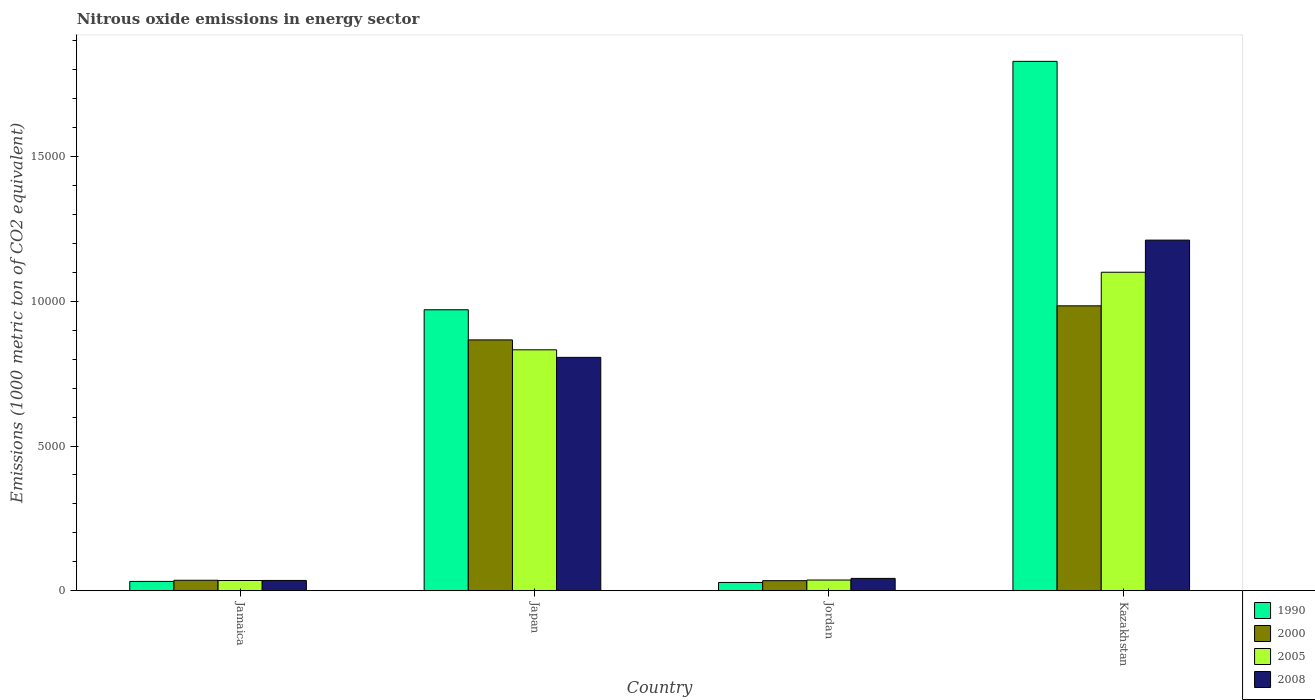How many groups of bars are there?
Offer a terse response. 4. Are the number of bars per tick equal to the number of legend labels?
Offer a very short reply. Yes. Are the number of bars on each tick of the X-axis equal?
Your answer should be compact. Yes. How many bars are there on the 3rd tick from the right?
Your response must be concise. 4. What is the label of the 1st group of bars from the left?
Give a very brief answer. Jamaica. In how many cases, is the number of bars for a given country not equal to the number of legend labels?
Provide a short and direct response. 0. What is the amount of nitrous oxide emitted in 2005 in Japan?
Offer a very short reply. 8324.7. Across all countries, what is the maximum amount of nitrous oxide emitted in 1990?
Give a very brief answer. 1.83e+04. Across all countries, what is the minimum amount of nitrous oxide emitted in 1990?
Make the answer very short. 285.6. In which country was the amount of nitrous oxide emitted in 2005 maximum?
Ensure brevity in your answer.  Kazakhstan. In which country was the amount of nitrous oxide emitted in 2000 minimum?
Ensure brevity in your answer.  Jordan. What is the total amount of nitrous oxide emitted in 2000 in the graph?
Your response must be concise. 1.92e+04. What is the difference between the amount of nitrous oxide emitted in 2008 in Jamaica and that in Jordan?
Your answer should be very brief. -70.9. What is the difference between the amount of nitrous oxide emitted in 1990 in Jamaica and the amount of nitrous oxide emitted in 2008 in Kazakhstan?
Provide a succinct answer. -1.18e+04. What is the average amount of nitrous oxide emitted in 2000 per country?
Your answer should be very brief. 4805.08. What is the difference between the amount of nitrous oxide emitted of/in 2005 and amount of nitrous oxide emitted of/in 2008 in Jamaica?
Your answer should be compact. -1.3. In how many countries, is the amount of nitrous oxide emitted in 1990 greater than 6000 1000 metric ton?
Provide a short and direct response. 2. What is the ratio of the amount of nitrous oxide emitted in 2000 in Jordan to that in Kazakhstan?
Provide a succinct answer. 0.04. Is the difference between the amount of nitrous oxide emitted in 2005 in Japan and Jordan greater than the difference between the amount of nitrous oxide emitted in 2008 in Japan and Jordan?
Your answer should be compact. Yes. What is the difference between the highest and the second highest amount of nitrous oxide emitted in 1990?
Ensure brevity in your answer.  -1.80e+04. What is the difference between the highest and the lowest amount of nitrous oxide emitted in 2005?
Offer a very short reply. 1.07e+04. In how many countries, is the amount of nitrous oxide emitted in 2008 greater than the average amount of nitrous oxide emitted in 2008 taken over all countries?
Your response must be concise. 2. Is it the case that in every country, the sum of the amount of nitrous oxide emitted in 2005 and amount of nitrous oxide emitted in 2000 is greater than the sum of amount of nitrous oxide emitted in 1990 and amount of nitrous oxide emitted in 2008?
Keep it short and to the point. No. How many bars are there?
Offer a very short reply. 16. How many countries are there in the graph?
Offer a very short reply. 4. Are the values on the major ticks of Y-axis written in scientific E-notation?
Offer a terse response. No. Does the graph contain grids?
Offer a terse response. No. Where does the legend appear in the graph?
Give a very brief answer. Bottom right. How are the legend labels stacked?
Give a very brief answer. Vertical. What is the title of the graph?
Offer a terse response. Nitrous oxide emissions in energy sector. What is the label or title of the X-axis?
Keep it short and to the point. Country. What is the label or title of the Y-axis?
Offer a very short reply. Emissions (1000 metric ton of CO2 equivalent). What is the Emissions (1000 metric ton of CO2 equivalent) in 1990 in Jamaica?
Offer a very short reply. 321.7. What is the Emissions (1000 metric ton of CO2 equivalent) of 2000 in Jamaica?
Provide a short and direct response. 361.6. What is the Emissions (1000 metric ton of CO2 equivalent) in 2005 in Jamaica?
Keep it short and to the point. 353.5. What is the Emissions (1000 metric ton of CO2 equivalent) of 2008 in Jamaica?
Offer a very short reply. 354.8. What is the Emissions (1000 metric ton of CO2 equivalent) of 1990 in Japan?
Your answer should be very brief. 9708.8. What is the Emissions (1000 metric ton of CO2 equivalent) in 2000 in Japan?
Ensure brevity in your answer.  8667.2. What is the Emissions (1000 metric ton of CO2 equivalent) of 2005 in Japan?
Offer a very short reply. 8324.7. What is the Emissions (1000 metric ton of CO2 equivalent) of 2008 in Japan?
Offer a very short reply. 8063.7. What is the Emissions (1000 metric ton of CO2 equivalent) in 1990 in Jordan?
Make the answer very short. 285.6. What is the Emissions (1000 metric ton of CO2 equivalent) in 2000 in Jordan?
Make the answer very short. 347.2. What is the Emissions (1000 metric ton of CO2 equivalent) in 2005 in Jordan?
Your answer should be compact. 369.5. What is the Emissions (1000 metric ton of CO2 equivalent) of 2008 in Jordan?
Ensure brevity in your answer.  425.7. What is the Emissions (1000 metric ton of CO2 equivalent) of 1990 in Kazakhstan?
Provide a succinct answer. 1.83e+04. What is the Emissions (1000 metric ton of CO2 equivalent) of 2000 in Kazakhstan?
Provide a succinct answer. 9844.3. What is the Emissions (1000 metric ton of CO2 equivalent) in 2005 in Kazakhstan?
Make the answer very short. 1.10e+04. What is the Emissions (1000 metric ton of CO2 equivalent) in 2008 in Kazakhstan?
Your response must be concise. 1.21e+04. Across all countries, what is the maximum Emissions (1000 metric ton of CO2 equivalent) of 1990?
Make the answer very short. 1.83e+04. Across all countries, what is the maximum Emissions (1000 metric ton of CO2 equivalent) of 2000?
Provide a short and direct response. 9844.3. Across all countries, what is the maximum Emissions (1000 metric ton of CO2 equivalent) in 2005?
Make the answer very short. 1.10e+04. Across all countries, what is the maximum Emissions (1000 metric ton of CO2 equivalent) of 2008?
Your answer should be very brief. 1.21e+04. Across all countries, what is the minimum Emissions (1000 metric ton of CO2 equivalent) of 1990?
Keep it short and to the point. 285.6. Across all countries, what is the minimum Emissions (1000 metric ton of CO2 equivalent) in 2000?
Offer a very short reply. 347.2. Across all countries, what is the minimum Emissions (1000 metric ton of CO2 equivalent) in 2005?
Provide a succinct answer. 353.5. Across all countries, what is the minimum Emissions (1000 metric ton of CO2 equivalent) in 2008?
Make the answer very short. 354.8. What is the total Emissions (1000 metric ton of CO2 equivalent) in 1990 in the graph?
Make the answer very short. 2.86e+04. What is the total Emissions (1000 metric ton of CO2 equivalent) in 2000 in the graph?
Give a very brief answer. 1.92e+04. What is the total Emissions (1000 metric ton of CO2 equivalent) of 2005 in the graph?
Provide a succinct answer. 2.01e+04. What is the total Emissions (1000 metric ton of CO2 equivalent) of 2008 in the graph?
Provide a succinct answer. 2.10e+04. What is the difference between the Emissions (1000 metric ton of CO2 equivalent) of 1990 in Jamaica and that in Japan?
Offer a very short reply. -9387.1. What is the difference between the Emissions (1000 metric ton of CO2 equivalent) in 2000 in Jamaica and that in Japan?
Your answer should be very brief. -8305.6. What is the difference between the Emissions (1000 metric ton of CO2 equivalent) of 2005 in Jamaica and that in Japan?
Provide a succinct answer. -7971.2. What is the difference between the Emissions (1000 metric ton of CO2 equivalent) of 2008 in Jamaica and that in Japan?
Your response must be concise. -7708.9. What is the difference between the Emissions (1000 metric ton of CO2 equivalent) in 1990 in Jamaica and that in Jordan?
Your answer should be compact. 36.1. What is the difference between the Emissions (1000 metric ton of CO2 equivalent) in 2008 in Jamaica and that in Jordan?
Make the answer very short. -70.9. What is the difference between the Emissions (1000 metric ton of CO2 equivalent) in 1990 in Jamaica and that in Kazakhstan?
Your response must be concise. -1.80e+04. What is the difference between the Emissions (1000 metric ton of CO2 equivalent) of 2000 in Jamaica and that in Kazakhstan?
Offer a very short reply. -9482.7. What is the difference between the Emissions (1000 metric ton of CO2 equivalent) in 2005 in Jamaica and that in Kazakhstan?
Your response must be concise. -1.07e+04. What is the difference between the Emissions (1000 metric ton of CO2 equivalent) in 2008 in Jamaica and that in Kazakhstan?
Make the answer very short. -1.18e+04. What is the difference between the Emissions (1000 metric ton of CO2 equivalent) of 1990 in Japan and that in Jordan?
Offer a very short reply. 9423.2. What is the difference between the Emissions (1000 metric ton of CO2 equivalent) of 2000 in Japan and that in Jordan?
Your response must be concise. 8320. What is the difference between the Emissions (1000 metric ton of CO2 equivalent) of 2005 in Japan and that in Jordan?
Your answer should be very brief. 7955.2. What is the difference between the Emissions (1000 metric ton of CO2 equivalent) in 2008 in Japan and that in Jordan?
Keep it short and to the point. 7638. What is the difference between the Emissions (1000 metric ton of CO2 equivalent) of 1990 in Japan and that in Kazakhstan?
Your response must be concise. -8583.7. What is the difference between the Emissions (1000 metric ton of CO2 equivalent) of 2000 in Japan and that in Kazakhstan?
Your response must be concise. -1177.1. What is the difference between the Emissions (1000 metric ton of CO2 equivalent) in 2005 in Japan and that in Kazakhstan?
Your response must be concise. -2680.3. What is the difference between the Emissions (1000 metric ton of CO2 equivalent) of 2008 in Japan and that in Kazakhstan?
Offer a terse response. -4051.4. What is the difference between the Emissions (1000 metric ton of CO2 equivalent) in 1990 in Jordan and that in Kazakhstan?
Your response must be concise. -1.80e+04. What is the difference between the Emissions (1000 metric ton of CO2 equivalent) in 2000 in Jordan and that in Kazakhstan?
Provide a succinct answer. -9497.1. What is the difference between the Emissions (1000 metric ton of CO2 equivalent) of 2005 in Jordan and that in Kazakhstan?
Your answer should be very brief. -1.06e+04. What is the difference between the Emissions (1000 metric ton of CO2 equivalent) of 2008 in Jordan and that in Kazakhstan?
Keep it short and to the point. -1.17e+04. What is the difference between the Emissions (1000 metric ton of CO2 equivalent) of 1990 in Jamaica and the Emissions (1000 metric ton of CO2 equivalent) of 2000 in Japan?
Offer a very short reply. -8345.5. What is the difference between the Emissions (1000 metric ton of CO2 equivalent) of 1990 in Jamaica and the Emissions (1000 metric ton of CO2 equivalent) of 2005 in Japan?
Provide a short and direct response. -8003. What is the difference between the Emissions (1000 metric ton of CO2 equivalent) in 1990 in Jamaica and the Emissions (1000 metric ton of CO2 equivalent) in 2008 in Japan?
Offer a terse response. -7742. What is the difference between the Emissions (1000 metric ton of CO2 equivalent) in 2000 in Jamaica and the Emissions (1000 metric ton of CO2 equivalent) in 2005 in Japan?
Provide a succinct answer. -7963.1. What is the difference between the Emissions (1000 metric ton of CO2 equivalent) of 2000 in Jamaica and the Emissions (1000 metric ton of CO2 equivalent) of 2008 in Japan?
Keep it short and to the point. -7702.1. What is the difference between the Emissions (1000 metric ton of CO2 equivalent) in 2005 in Jamaica and the Emissions (1000 metric ton of CO2 equivalent) in 2008 in Japan?
Provide a succinct answer. -7710.2. What is the difference between the Emissions (1000 metric ton of CO2 equivalent) in 1990 in Jamaica and the Emissions (1000 metric ton of CO2 equivalent) in 2000 in Jordan?
Offer a terse response. -25.5. What is the difference between the Emissions (1000 metric ton of CO2 equivalent) in 1990 in Jamaica and the Emissions (1000 metric ton of CO2 equivalent) in 2005 in Jordan?
Your answer should be compact. -47.8. What is the difference between the Emissions (1000 metric ton of CO2 equivalent) of 1990 in Jamaica and the Emissions (1000 metric ton of CO2 equivalent) of 2008 in Jordan?
Your response must be concise. -104. What is the difference between the Emissions (1000 metric ton of CO2 equivalent) in 2000 in Jamaica and the Emissions (1000 metric ton of CO2 equivalent) in 2005 in Jordan?
Your answer should be compact. -7.9. What is the difference between the Emissions (1000 metric ton of CO2 equivalent) in 2000 in Jamaica and the Emissions (1000 metric ton of CO2 equivalent) in 2008 in Jordan?
Your answer should be very brief. -64.1. What is the difference between the Emissions (1000 metric ton of CO2 equivalent) of 2005 in Jamaica and the Emissions (1000 metric ton of CO2 equivalent) of 2008 in Jordan?
Your response must be concise. -72.2. What is the difference between the Emissions (1000 metric ton of CO2 equivalent) of 1990 in Jamaica and the Emissions (1000 metric ton of CO2 equivalent) of 2000 in Kazakhstan?
Provide a succinct answer. -9522.6. What is the difference between the Emissions (1000 metric ton of CO2 equivalent) of 1990 in Jamaica and the Emissions (1000 metric ton of CO2 equivalent) of 2005 in Kazakhstan?
Your answer should be very brief. -1.07e+04. What is the difference between the Emissions (1000 metric ton of CO2 equivalent) in 1990 in Jamaica and the Emissions (1000 metric ton of CO2 equivalent) in 2008 in Kazakhstan?
Offer a very short reply. -1.18e+04. What is the difference between the Emissions (1000 metric ton of CO2 equivalent) in 2000 in Jamaica and the Emissions (1000 metric ton of CO2 equivalent) in 2005 in Kazakhstan?
Offer a very short reply. -1.06e+04. What is the difference between the Emissions (1000 metric ton of CO2 equivalent) in 2000 in Jamaica and the Emissions (1000 metric ton of CO2 equivalent) in 2008 in Kazakhstan?
Give a very brief answer. -1.18e+04. What is the difference between the Emissions (1000 metric ton of CO2 equivalent) of 2005 in Jamaica and the Emissions (1000 metric ton of CO2 equivalent) of 2008 in Kazakhstan?
Offer a very short reply. -1.18e+04. What is the difference between the Emissions (1000 metric ton of CO2 equivalent) in 1990 in Japan and the Emissions (1000 metric ton of CO2 equivalent) in 2000 in Jordan?
Your answer should be very brief. 9361.6. What is the difference between the Emissions (1000 metric ton of CO2 equivalent) in 1990 in Japan and the Emissions (1000 metric ton of CO2 equivalent) in 2005 in Jordan?
Provide a succinct answer. 9339.3. What is the difference between the Emissions (1000 metric ton of CO2 equivalent) in 1990 in Japan and the Emissions (1000 metric ton of CO2 equivalent) in 2008 in Jordan?
Give a very brief answer. 9283.1. What is the difference between the Emissions (1000 metric ton of CO2 equivalent) in 2000 in Japan and the Emissions (1000 metric ton of CO2 equivalent) in 2005 in Jordan?
Offer a terse response. 8297.7. What is the difference between the Emissions (1000 metric ton of CO2 equivalent) in 2000 in Japan and the Emissions (1000 metric ton of CO2 equivalent) in 2008 in Jordan?
Your response must be concise. 8241.5. What is the difference between the Emissions (1000 metric ton of CO2 equivalent) in 2005 in Japan and the Emissions (1000 metric ton of CO2 equivalent) in 2008 in Jordan?
Offer a terse response. 7899. What is the difference between the Emissions (1000 metric ton of CO2 equivalent) in 1990 in Japan and the Emissions (1000 metric ton of CO2 equivalent) in 2000 in Kazakhstan?
Provide a short and direct response. -135.5. What is the difference between the Emissions (1000 metric ton of CO2 equivalent) in 1990 in Japan and the Emissions (1000 metric ton of CO2 equivalent) in 2005 in Kazakhstan?
Ensure brevity in your answer.  -1296.2. What is the difference between the Emissions (1000 metric ton of CO2 equivalent) in 1990 in Japan and the Emissions (1000 metric ton of CO2 equivalent) in 2008 in Kazakhstan?
Your answer should be compact. -2406.3. What is the difference between the Emissions (1000 metric ton of CO2 equivalent) of 2000 in Japan and the Emissions (1000 metric ton of CO2 equivalent) of 2005 in Kazakhstan?
Ensure brevity in your answer.  -2337.8. What is the difference between the Emissions (1000 metric ton of CO2 equivalent) in 2000 in Japan and the Emissions (1000 metric ton of CO2 equivalent) in 2008 in Kazakhstan?
Provide a succinct answer. -3447.9. What is the difference between the Emissions (1000 metric ton of CO2 equivalent) in 2005 in Japan and the Emissions (1000 metric ton of CO2 equivalent) in 2008 in Kazakhstan?
Offer a terse response. -3790.4. What is the difference between the Emissions (1000 metric ton of CO2 equivalent) of 1990 in Jordan and the Emissions (1000 metric ton of CO2 equivalent) of 2000 in Kazakhstan?
Your response must be concise. -9558.7. What is the difference between the Emissions (1000 metric ton of CO2 equivalent) of 1990 in Jordan and the Emissions (1000 metric ton of CO2 equivalent) of 2005 in Kazakhstan?
Give a very brief answer. -1.07e+04. What is the difference between the Emissions (1000 metric ton of CO2 equivalent) in 1990 in Jordan and the Emissions (1000 metric ton of CO2 equivalent) in 2008 in Kazakhstan?
Make the answer very short. -1.18e+04. What is the difference between the Emissions (1000 metric ton of CO2 equivalent) of 2000 in Jordan and the Emissions (1000 metric ton of CO2 equivalent) of 2005 in Kazakhstan?
Keep it short and to the point. -1.07e+04. What is the difference between the Emissions (1000 metric ton of CO2 equivalent) of 2000 in Jordan and the Emissions (1000 metric ton of CO2 equivalent) of 2008 in Kazakhstan?
Offer a very short reply. -1.18e+04. What is the difference between the Emissions (1000 metric ton of CO2 equivalent) of 2005 in Jordan and the Emissions (1000 metric ton of CO2 equivalent) of 2008 in Kazakhstan?
Ensure brevity in your answer.  -1.17e+04. What is the average Emissions (1000 metric ton of CO2 equivalent) of 1990 per country?
Your answer should be compact. 7152.15. What is the average Emissions (1000 metric ton of CO2 equivalent) in 2000 per country?
Offer a very short reply. 4805.07. What is the average Emissions (1000 metric ton of CO2 equivalent) of 2005 per country?
Your response must be concise. 5013.18. What is the average Emissions (1000 metric ton of CO2 equivalent) in 2008 per country?
Give a very brief answer. 5239.82. What is the difference between the Emissions (1000 metric ton of CO2 equivalent) in 1990 and Emissions (1000 metric ton of CO2 equivalent) in 2000 in Jamaica?
Your response must be concise. -39.9. What is the difference between the Emissions (1000 metric ton of CO2 equivalent) of 1990 and Emissions (1000 metric ton of CO2 equivalent) of 2005 in Jamaica?
Make the answer very short. -31.8. What is the difference between the Emissions (1000 metric ton of CO2 equivalent) of 1990 and Emissions (1000 metric ton of CO2 equivalent) of 2008 in Jamaica?
Provide a succinct answer. -33.1. What is the difference between the Emissions (1000 metric ton of CO2 equivalent) in 2000 and Emissions (1000 metric ton of CO2 equivalent) in 2005 in Jamaica?
Make the answer very short. 8.1. What is the difference between the Emissions (1000 metric ton of CO2 equivalent) in 2000 and Emissions (1000 metric ton of CO2 equivalent) in 2008 in Jamaica?
Offer a very short reply. 6.8. What is the difference between the Emissions (1000 metric ton of CO2 equivalent) of 1990 and Emissions (1000 metric ton of CO2 equivalent) of 2000 in Japan?
Keep it short and to the point. 1041.6. What is the difference between the Emissions (1000 metric ton of CO2 equivalent) of 1990 and Emissions (1000 metric ton of CO2 equivalent) of 2005 in Japan?
Your response must be concise. 1384.1. What is the difference between the Emissions (1000 metric ton of CO2 equivalent) of 1990 and Emissions (1000 metric ton of CO2 equivalent) of 2008 in Japan?
Offer a very short reply. 1645.1. What is the difference between the Emissions (1000 metric ton of CO2 equivalent) in 2000 and Emissions (1000 metric ton of CO2 equivalent) in 2005 in Japan?
Your answer should be compact. 342.5. What is the difference between the Emissions (1000 metric ton of CO2 equivalent) in 2000 and Emissions (1000 metric ton of CO2 equivalent) in 2008 in Japan?
Offer a very short reply. 603.5. What is the difference between the Emissions (1000 metric ton of CO2 equivalent) in 2005 and Emissions (1000 metric ton of CO2 equivalent) in 2008 in Japan?
Your answer should be very brief. 261. What is the difference between the Emissions (1000 metric ton of CO2 equivalent) in 1990 and Emissions (1000 metric ton of CO2 equivalent) in 2000 in Jordan?
Give a very brief answer. -61.6. What is the difference between the Emissions (1000 metric ton of CO2 equivalent) of 1990 and Emissions (1000 metric ton of CO2 equivalent) of 2005 in Jordan?
Provide a short and direct response. -83.9. What is the difference between the Emissions (1000 metric ton of CO2 equivalent) of 1990 and Emissions (1000 metric ton of CO2 equivalent) of 2008 in Jordan?
Offer a terse response. -140.1. What is the difference between the Emissions (1000 metric ton of CO2 equivalent) of 2000 and Emissions (1000 metric ton of CO2 equivalent) of 2005 in Jordan?
Provide a succinct answer. -22.3. What is the difference between the Emissions (1000 metric ton of CO2 equivalent) of 2000 and Emissions (1000 metric ton of CO2 equivalent) of 2008 in Jordan?
Provide a succinct answer. -78.5. What is the difference between the Emissions (1000 metric ton of CO2 equivalent) in 2005 and Emissions (1000 metric ton of CO2 equivalent) in 2008 in Jordan?
Your answer should be compact. -56.2. What is the difference between the Emissions (1000 metric ton of CO2 equivalent) of 1990 and Emissions (1000 metric ton of CO2 equivalent) of 2000 in Kazakhstan?
Your answer should be very brief. 8448.2. What is the difference between the Emissions (1000 metric ton of CO2 equivalent) in 1990 and Emissions (1000 metric ton of CO2 equivalent) in 2005 in Kazakhstan?
Provide a short and direct response. 7287.5. What is the difference between the Emissions (1000 metric ton of CO2 equivalent) of 1990 and Emissions (1000 metric ton of CO2 equivalent) of 2008 in Kazakhstan?
Ensure brevity in your answer.  6177.4. What is the difference between the Emissions (1000 metric ton of CO2 equivalent) in 2000 and Emissions (1000 metric ton of CO2 equivalent) in 2005 in Kazakhstan?
Provide a short and direct response. -1160.7. What is the difference between the Emissions (1000 metric ton of CO2 equivalent) in 2000 and Emissions (1000 metric ton of CO2 equivalent) in 2008 in Kazakhstan?
Offer a very short reply. -2270.8. What is the difference between the Emissions (1000 metric ton of CO2 equivalent) of 2005 and Emissions (1000 metric ton of CO2 equivalent) of 2008 in Kazakhstan?
Give a very brief answer. -1110.1. What is the ratio of the Emissions (1000 metric ton of CO2 equivalent) of 1990 in Jamaica to that in Japan?
Ensure brevity in your answer.  0.03. What is the ratio of the Emissions (1000 metric ton of CO2 equivalent) in 2000 in Jamaica to that in Japan?
Offer a terse response. 0.04. What is the ratio of the Emissions (1000 metric ton of CO2 equivalent) in 2005 in Jamaica to that in Japan?
Provide a short and direct response. 0.04. What is the ratio of the Emissions (1000 metric ton of CO2 equivalent) of 2008 in Jamaica to that in Japan?
Make the answer very short. 0.04. What is the ratio of the Emissions (1000 metric ton of CO2 equivalent) in 1990 in Jamaica to that in Jordan?
Offer a very short reply. 1.13. What is the ratio of the Emissions (1000 metric ton of CO2 equivalent) in 2000 in Jamaica to that in Jordan?
Offer a terse response. 1.04. What is the ratio of the Emissions (1000 metric ton of CO2 equivalent) of 2005 in Jamaica to that in Jordan?
Offer a very short reply. 0.96. What is the ratio of the Emissions (1000 metric ton of CO2 equivalent) in 2008 in Jamaica to that in Jordan?
Offer a very short reply. 0.83. What is the ratio of the Emissions (1000 metric ton of CO2 equivalent) in 1990 in Jamaica to that in Kazakhstan?
Provide a short and direct response. 0.02. What is the ratio of the Emissions (1000 metric ton of CO2 equivalent) of 2000 in Jamaica to that in Kazakhstan?
Provide a short and direct response. 0.04. What is the ratio of the Emissions (1000 metric ton of CO2 equivalent) in 2005 in Jamaica to that in Kazakhstan?
Ensure brevity in your answer.  0.03. What is the ratio of the Emissions (1000 metric ton of CO2 equivalent) in 2008 in Jamaica to that in Kazakhstan?
Your answer should be very brief. 0.03. What is the ratio of the Emissions (1000 metric ton of CO2 equivalent) in 1990 in Japan to that in Jordan?
Ensure brevity in your answer.  33.99. What is the ratio of the Emissions (1000 metric ton of CO2 equivalent) in 2000 in Japan to that in Jordan?
Ensure brevity in your answer.  24.96. What is the ratio of the Emissions (1000 metric ton of CO2 equivalent) of 2005 in Japan to that in Jordan?
Offer a terse response. 22.53. What is the ratio of the Emissions (1000 metric ton of CO2 equivalent) of 2008 in Japan to that in Jordan?
Your answer should be compact. 18.94. What is the ratio of the Emissions (1000 metric ton of CO2 equivalent) in 1990 in Japan to that in Kazakhstan?
Ensure brevity in your answer.  0.53. What is the ratio of the Emissions (1000 metric ton of CO2 equivalent) in 2000 in Japan to that in Kazakhstan?
Keep it short and to the point. 0.88. What is the ratio of the Emissions (1000 metric ton of CO2 equivalent) of 2005 in Japan to that in Kazakhstan?
Your answer should be very brief. 0.76. What is the ratio of the Emissions (1000 metric ton of CO2 equivalent) in 2008 in Japan to that in Kazakhstan?
Provide a succinct answer. 0.67. What is the ratio of the Emissions (1000 metric ton of CO2 equivalent) in 1990 in Jordan to that in Kazakhstan?
Provide a succinct answer. 0.02. What is the ratio of the Emissions (1000 metric ton of CO2 equivalent) in 2000 in Jordan to that in Kazakhstan?
Ensure brevity in your answer.  0.04. What is the ratio of the Emissions (1000 metric ton of CO2 equivalent) of 2005 in Jordan to that in Kazakhstan?
Offer a very short reply. 0.03. What is the ratio of the Emissions (1000 metric ton of CO2 equivalent) of 2008 in Jordan to that in Kazakhstan?
Keep it short and to the point. 0.04. What is the difference between the highest and the second highest Emissions (1000 metric ton of CO2 equivalent) in 1990?
Make the answer very short. 8583.7. What is the difference between the highest and the second highest Emissions (1000 metric ton of CO2 equivalent) in 2000?
Offer a terse response. 1177.1. What is the difference between the highest and the second highest Emissions (1000 metric ton of CO2 equivalent) in 2005?
Your answer should be very brief. 2680.3. What is the difference between the highest and the second highest Emissions (1000 metric ton of CO2 equivalent) of 2008?
Make the answer very short. 4051.4. What is the difference between the highest and the lowest Emissions (1000 metric ton of CO2 equivalent) of 1990?
Give a very brief answer. 1.80e+04. What is the difference between the highest and the lowest Emissions (1000 metric ton of CO2 equivalent) in 2000?
Provide a succinct answer. 9497.1. What is the difference between the highest and the lowest Emissions (1000 metric ton of CO2 equivalent) of 2005?
Your response must be concise. 1.07e+04. What is the difference between the highest and the lowest Emissions (1000 metric ton of CO2 equivalent) in 2008?
Give a very brief answer. 1.18e+04. 